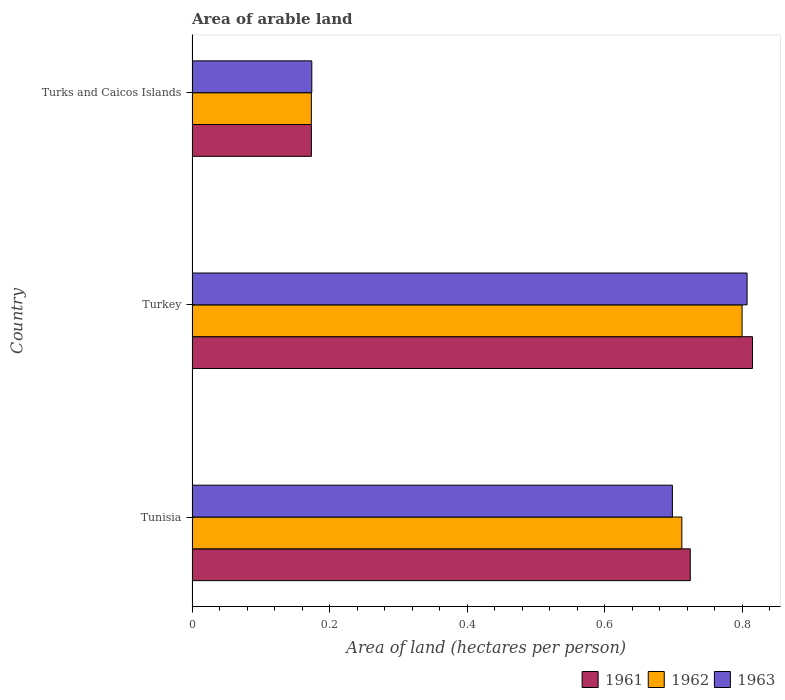Are the number of bars per tick equal to the number of legend labels?
Make the answer very short. Yes. How many bars are there on the 2nd tick from the top?
Provide a succinct answer. 3. What is the label of the 1st group of bars from the top?
Offer a very short reply. Turks and Caicos Islands. What is the total arable land in 1961 in Tunisia?
Your answer should be very brief. 0.72. Across all countries, what is the maximum total arable land in 1961?
Offer a very short reply. 0.82. Across all countries, what is the minimum total arable land in 1962?
Make the answer very short. 0.17. In which country was the total arable land in 1963 maximum?
Give a very brief answer. Turkey. In which country was the total arable land in 1962 minimum?
Offer a very short reply. Turks and Caicos Islands. What is the total total arable land in 1963 in the graph?
Provide a short and direct response. 1.68. What is the difference between the total arable land in 1961 in Tunisia and that in Turkey?
Offer a very short reply. -0.09. What is the difference between the total arable land in 1961 in Tunisia and the total arable land in 1962 in Turkey?
Your response must be concise. -0.08. What is the average total arable land in 1961 per country?
Give a very brief answer. 0.57. What is the difference between the total arable land in 1961 and total arable land in 1962 in Turks and Caicos Islands?
Give a very brief answer. 6.0260711943982415e-5. In how many countries, is the total arable land in 1962 greater than 0.36 hectares per person?
Your answer should be very brief. 2. What is the ratio of the total arable land in 1962 in Turkey to that in Turks and Caicos Islands?
Your answer should be compact. 4.61. What is the difference between the highest and the second highest total arable land in 1962?
Your response must be concise. 0.09. What is the difference between the highest and the lowest total arable land in 1963?
Provide a short and direct response. 0.63. Is it the case that in every country, the sum of the total arable land in 1962 and total arable land in 1963 is greater than the total arable land in 1961?
Offer a terse response. Yes. How many countries are there in the graph?
Ensure brevity in your answer.  3. Are the values on the major ticks of X-axis written in scientific E-notation?
Make the answer very short. No. Does the graph contain any zero values?
Make the answer very short. No. Does the graph contain grids?
Provide a short and direct response. No. What is the title of the graph?
Your answer should be compact. Area of arable land. Does "1997" appear as one of the legend labels in the graph?
Make the answer very short. No. What is the label or title of the X-axis?
Your response must be concise. Area of land (hectares per person). What is the Area of land (hectares per person) in 1961 in Tunisia?
Keep it short and to the point. 0.72. What is the Area of land (hectares per person) in 1962 in Tunisia?
Make the answer very short. 0.71. What is the Area of land (hectares per person) of 1963 in Tunisia?
Your answer should be very brief. 0.7. What is the Area of land (hectares per person) in 1961 in Turkey?
Your response must be concise. 0.82. What is the Area of land (hectares per person) in 1962 in Turkey?
Your answer should be very brief. 0.8. What is the Area of land (hectares per person) in 1963 in Turkey?
Provide a short and direct response. 0.81. What is the Area of land (hectares per person) in 1961 in Turks and Caicos Islands?
Make the answer very short. 0.17. What is the Area of land (hectares per person) in 1962 in Turks and Caicos Islands?
Make the answer very short. 0.17. What is the Area of land (hectares per person) of 1963 in Turks and Caicos Islands?
Provide a short and direct response. 0.17. Across all countries, what is the maximum Area of land (hectares per person) in 1961?
Give a very brief answer. 0.82. Across all countries, what is the maximum Area of land (hectares per person) in 1962?
Offer a terse response. 0.8. Across all countries, what is the maximum Area of land (hectares per person) of 1963?
Offer a very short reply. 0.81. Across all countries, what is the minimum Area of land (hectares per person) in 1961?
Ensure brevity in your answer.  0.17. Across all countries, what is the minimum Area of land (hectares per person) of 1962?
Your answer should be very brief. 0.17. Across all countries, what is the minimum Area of land (hectares per person) in 1963?
Keep it short and to the point. 0.17. What is the total Area of land (hectares per person) in 1961 in the graph?
Your answer should be very brief. 1.71. What is the total Area of land (hectares per person) in 1962 in the graph?
Offer a very short reply. 1.69. What is the total Area of land (hectares per person) in 1963 in the graph?
Provide a short and direct response. 1.68. What is the difference between the Area of land (hectares per person) of 1961 in Tunisia and that in Turkey?
Give a very brief answer. -0.09. What is the difference between the Area of land (hectares per person) of 1962 in Tunisia and that in Turkey?
Ensure brevity in your answer.  -0.09. What is the difference between the Area of land (hectares per person) of 1963 in Tunisia and that in Turkey?
Provide a succinct answer. -0.11. What is the difference between the Area of land (hectares per person) of 1961 in Tunisia and that in Turks and Caicos Islands?
Give a very brief answer. 0.55. What is the difference between the Area of land (hectares per person) in 1962 in Tunisia and that in Turks and Caicos Islands?
Offer a very short reply. 0.54. What is the difference between the Area of land (hectares per person) of 1963 in Tunisia and that in Turks and Caicos Islands?
Offer a very short reply. 0.52. What is the difference between the Area of land (hectares per person) in 1961 in Turkey and that in Turks and Caicos Islands?
Your answer should be very brief. 0.64. What is the difference between the Area of land (hectares per person) of 1962 in Turkey and that in Turks and Caicos Islands?
Provide a short and direct response. 0.63. What is the difference between the Area of land (hectares per person) in 1963 in Turkey and that in Turks and Caicos Islands?
Offer a very short reply. 0.63. What is the difference between the Area of land (hectares per person) in 1961 in Tunisia and the Area of land (hectares per person) in 1962 in Turkey?
Offer a very short reply. -0.08. What is the difference between the Area of land (hectares per person) in 1961 in Tunisia and the Area of land (hectares per person) in 1963 in Turkey?
Give a very brief answer. -0.08. What is the difference between the Area of land (hectares per person) of 1962 in Tunisia and the Area of land (hectares per person) of 1963 in Turkey?
Ensure brevity in your answer.  -0.09. What is the difference between the Area of land (hectares per person) of 1961 in Tunisia and the Area of land (hectares per person) of 1962 in Turks and Caicos Islands?
Keep it short and to the point. 0.55. What is the difference between the Area of land (hectares per person) in 1961 in Tunisia and the Area of land (hectares per person) in 1963 in Turks and Caicos Islands?
Your answer should be compact. 0.55. What is the difference between the Area of land (hectares per person) in 1962 in Tunisia and the Area of land (hectares per person) in 1963 in Turks and Caicos Islands?
Keep it short and to the point. 0.54. What is the difference between the Area of land (hectares per person) of 1961 in Turkey and the Area of land (hectares per person) of 1962 in Turks and Caicos Islands?
Offer a terse response. 0.64. What is the difference between the Area of land (hectares per person) of 1961 in Turkey and the Area of land (hectares per person) of 1963 in Turks and Caicos Islands?
Keep it short and to the point. 0.64. What is the difference between the Area of land (hectares per person) of 1962 in Turkey and the Area of land (hectares per person) of 1963 in Turks and Caicos Islands?
Offer a very short reply. 0.63. What is the average Area of land (hectares per person) in 1961 per country?
Provide a succinct answer. 0.57. What is the average Area of land (hectares per person) of 1962 per country?
Offer a very short reply. 0.56. What is the average Area of land (hectares per person) in 1963 per country?
Provide a succinct answer. 0.56. What is the difference between the Area of land (hectares per person) in 1961 and Area of land (hectares per person) in 1962 in Tunisia?
Ensure brevity in your answer.  0.01. What is the difference between the Area of land (hectares per person) of 1961 and Area of land (hectares per person) of 1963 in Tunisia?
Your answer should be compact. 0.03. What is the difference between the Area of land (hectares per person) of 1962 and Area of land (hectares per person) of 1963 in Tunisia?
Keep it short and to the point. 0.01. What is the difference between the Area of land (hectares per person) of 1961 and Area of land (hectares per person) of 1962 in Turkey?
Your answer should be very brief. 0.02. What is the difference between the Area of land (hectares per person) in 1961 and Area of land (hectares per person) in 1963 in Turkey?
Your response must be concise. 0.01. What is the difference between the Area of land (hectares per person) in 1962 and Area of land (hectares per person) in 1963 in Turkey?
Provide a succinct answer. -0.01. What is the difference between the Area of land (hectares per person) of 1961 and Area of land (hectares per person) of 1963 in Turks and Caicos Islands?
Ensure brevity in your answer.  -0. What is the difference between the Area of land (hectares per person) in 1962 and Area of land (hectares per person) in 1963 in Turks and Caicos Islands?
Offer a very short reply. -0. What is the ratio of the Area of land (hectares per person) in 1961 in Tunisia to that in Turkey?
Make the answer very short. 0.89. What is the ratio of the Area of land (hectares per person) in 1962 in Tunisia to that in Turkey?
Provide a short and direct response. 0.89. What is the ratio of the Area of land (hectares per person) in 1963 in Tunisia to that in Turkey?
Your answer should be compact. 0.87. What is the ratio of the Area of land (hectares per person) in 1961 in Tunisia to that in Turks and Caicos Islands?
Your answer should be compact. 4.17. What is the ratio of the Area of land (hectares per person) in 1962 in Tunisia to that in Turks and Caicos Islands?
Offer a very short reply. 4.11. What is the ratio of the Area of land (hectares per person) in 1963 in Tunisia to that in Turks and Caicos Islands?
Your response must be concise. 4.01. What is the ratio of the Area of land (hectares per person) of 1961 in Turkey to that in Turks and Caicos Islands?
Provide a succinct answer. 4.7. What is the ratio of the Area of land (hectares per person) of 1962 in Turkey to that in Turks and Caicos Islands?
Provide a succinct answer. 4.61. What is the ratio of the Area of land (hectares per person) of 1963 in Turkey to that in Turks and Caicos Islands?
Your answer should be very brief. 4.63. What is the difference between the highest and the second highest Area of land (hectares per person) in 1961?
Provide a succinct answer. 0.09. What is the difference between the highest and the second highest Area of land (hectares per person) in 1962?
Your response must be concise. 0.09. What is the difference between the highest and the second highest Area of land (hectares per person) in 1963?
Your answer should be very brief. 0.11. What is the difference between the highest and the lowest Area of land (hectares per person) of 1961?
Offer a very short reply. 0.64. What is the difference between the highest and the lowest Area of land (hectares per person) in 1962?
Your answer should be compact. 0.63. What is the difference between the highest and the lowest Area of land (hectares per person) of 1963?
Offer a terse response. 0.63. 